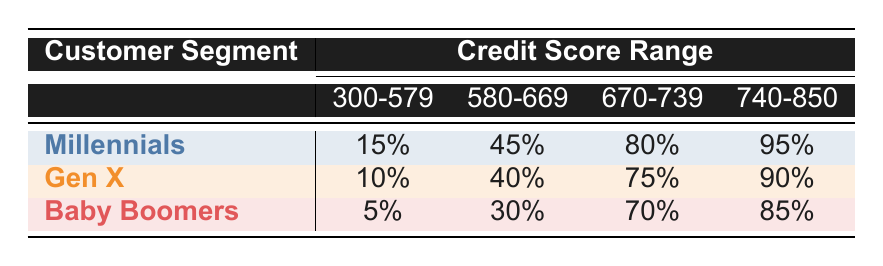What is the loan approval rate for Baby Boomers with a credit score range of 740-850? In the table, look under the row for Baby Boomers and find the column for the credit score range of 740-850. The value in that cell is 85%.
Answer: 85% Which customer segment has the highest loan approval rate for those with credit scores between 670-739? By examining the row for each customer segment under the 670-739 column, Millennials have an approval rate of 80%, Gen X has 75%, and Baby Boomers have 70%. Therefore, Millennials have the highest rate.
Answer: Millennials What is the difference in loan approval rates between Millennials and Gen X for credit scores ranging from 580-669? The approval rate for Millennials in the 580-669 range is 45%, while for Gen X it is 40%. To find the difference, subtract Gen X's rate from Millennials' rate: 45% - 40% = 5%.
Answer: 5% Is it true that the loan approval rates for Baby Boomers are lower than those for Millennials across all credit score ranges? To check this, compare the approval rates for each credit score range. For the 300-579 range, Baby Boomers (5%) have a lower rate than Millennials (15%). For 580-669, Baby Boomers (30%) are again lower than Millennials (45%). For 670-739, Baby Boomers (70%) are also lower than Millennials (80%). Finally, for 740-850, Baby Boomers (85%) are lower than Millennials (95%). Thus, the statement is true.
Answer: Yes What is the average loan approval rate for each customer segment? To find the average, sum the approval rates for each segment and divide by the number of credit score ranges (4): For Millennials: (15 + 45 + 80 + 95) / 4 = 58.75%. For Gen X: (10 + 40 + 75 + 90) / 4 = 53.75%. For Baby Boomers: (5 + 30 + 70 + 85) / 4 = 47.5%. Hence, the averages are 58.75% for Millennials, 53.75% for Gen X, and 47.5% for Baby Boomers.
Answer: Millennials: 58.75%, Gen X: 53.75%, Baby Boomers: 47.5% 